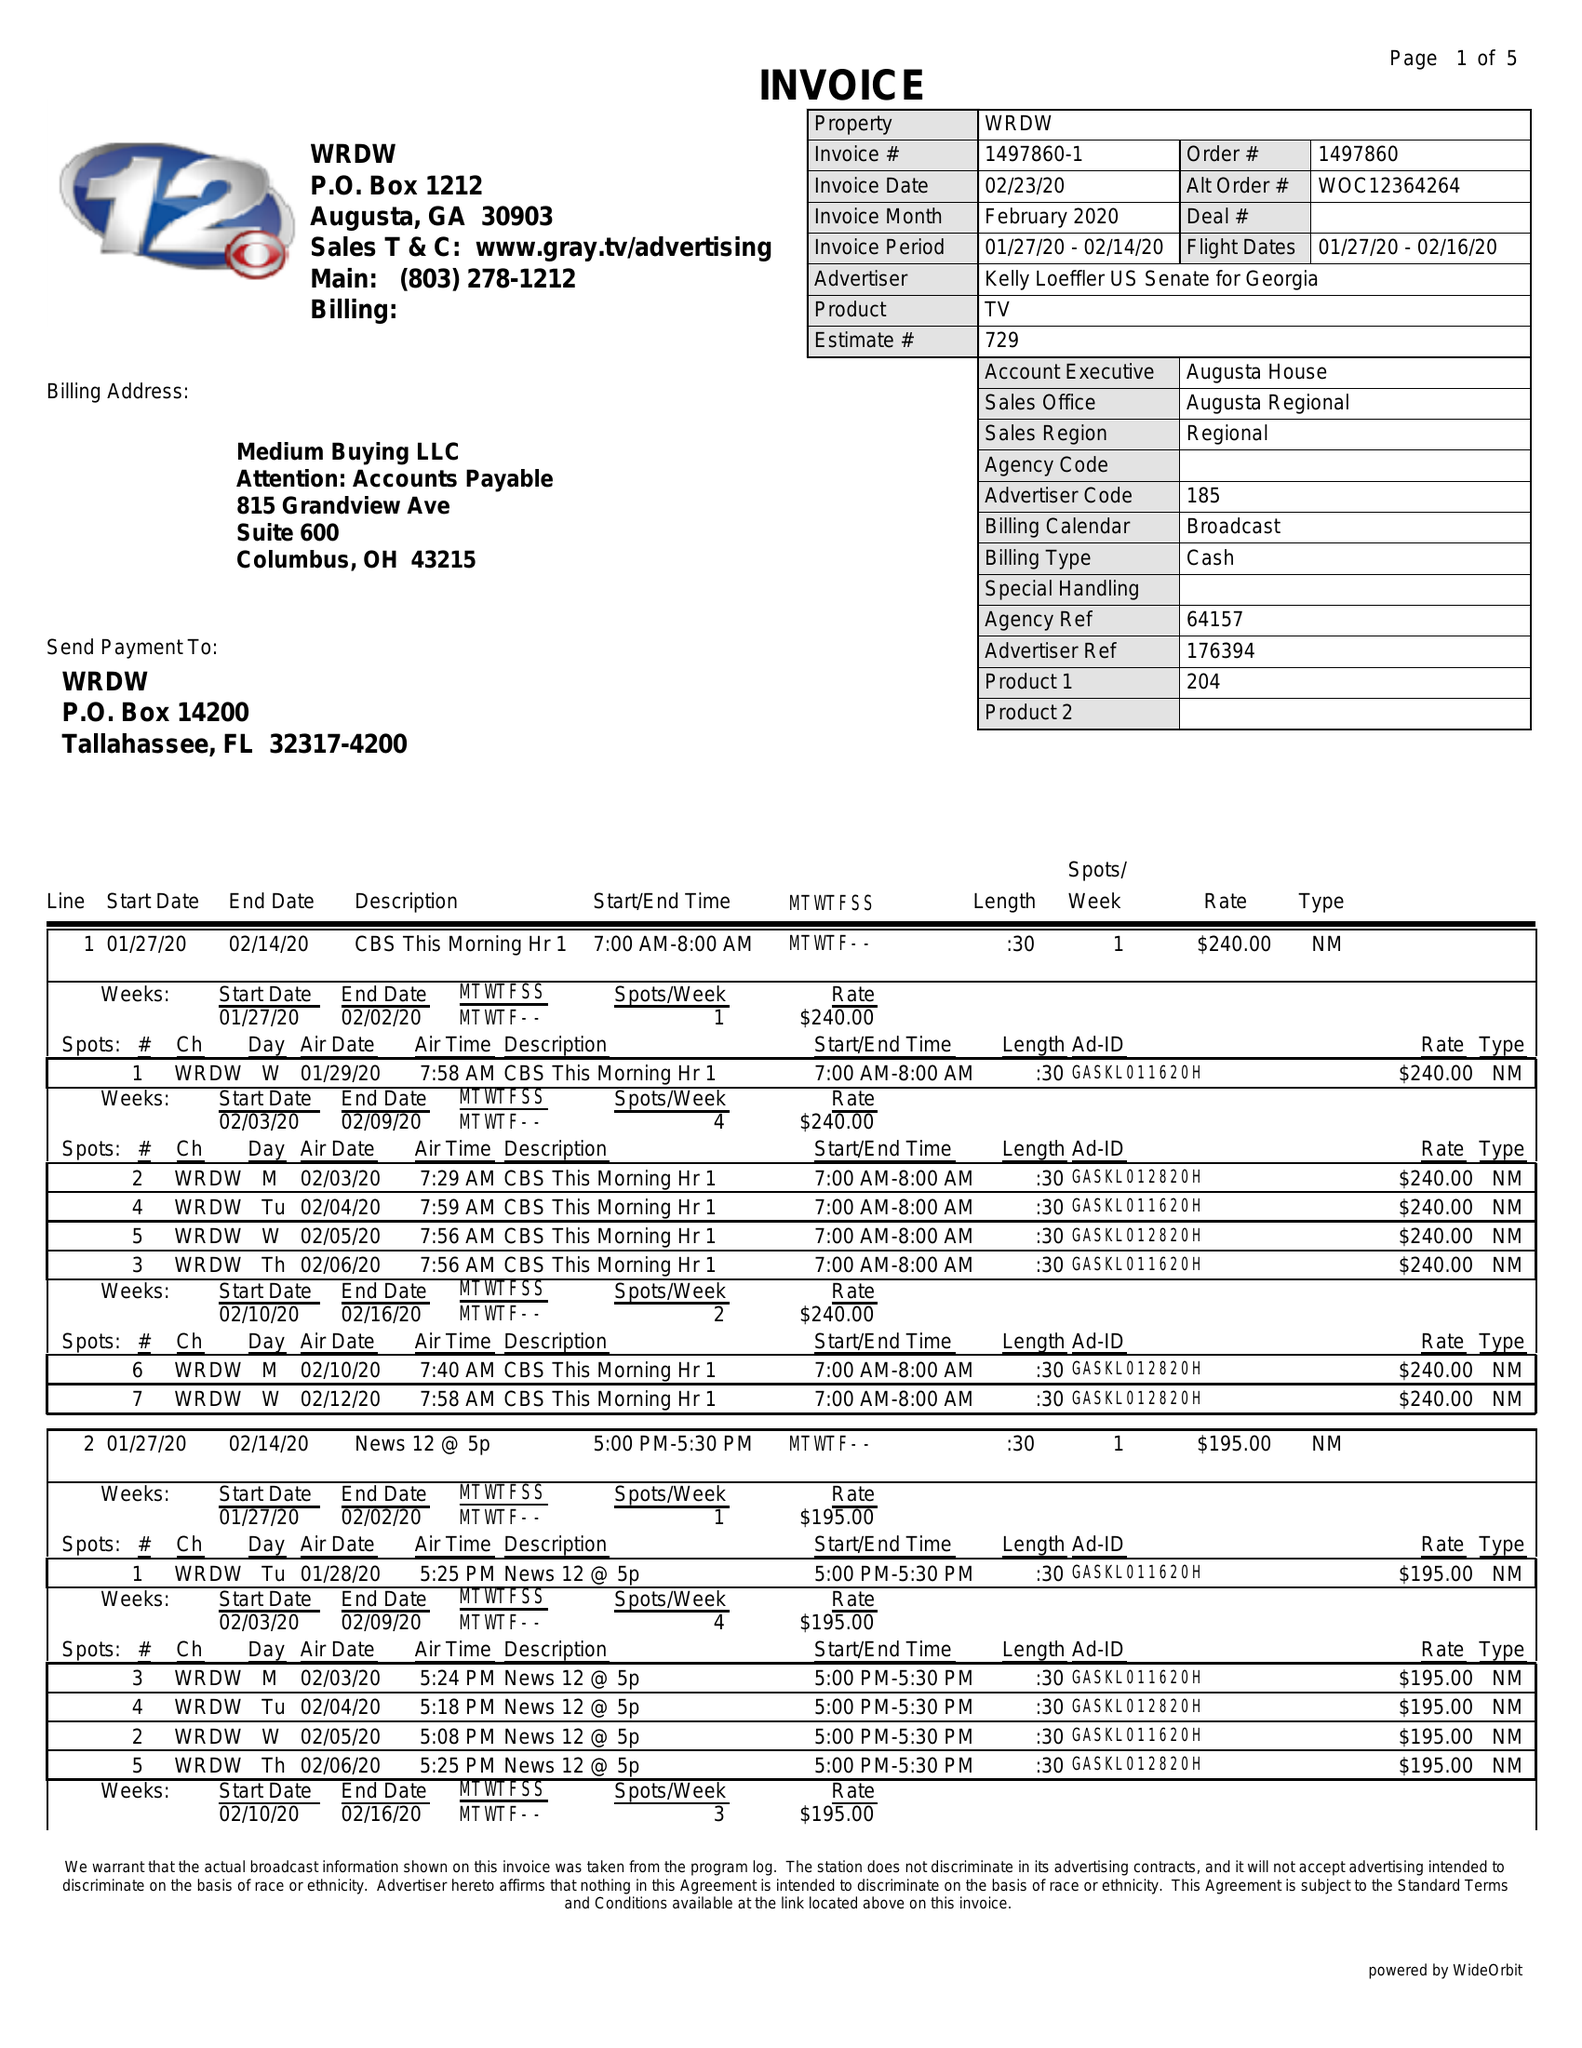What is the value for the flight_from?
Answer the question using a single word or phrase. 01/27/20 